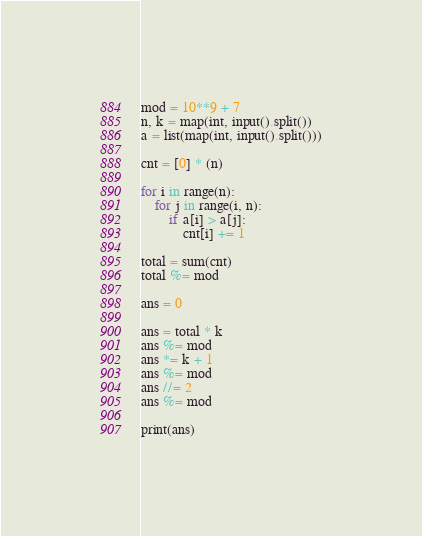<code> <loc_0><loc_0><loc_500><loc_500><_Python_>mod = 10**9 + 7
n, k = map(int, input().split())
a = list(map(int, input().split()))

cnt = [0] * (n)

for i in range(n):
    for j in range(i, n):
        if a[i] > a[j]:
            cnt[i] += 1

total = sum(cnt)
total %= mod

ans = 0

ans = total * k
ans %= mod
ans *= k + 1
ans %= mod
ans //= 2
ans %= mod

print(ans)</code> 